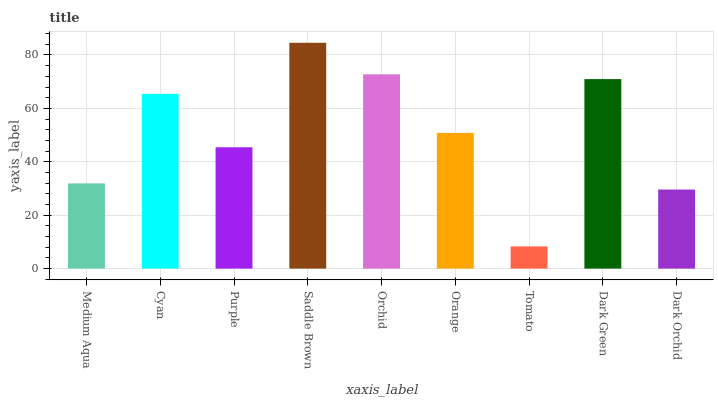Is Tomato the minimum?
Answer yes or no. Yes. Is Saddle Brown the maximum?
Answer yes or no. Yes. Is Cyan the minimum?
Answer yes or no. No. Is Cyan the maximum?
Answer yes or no. No. Is Cyan greater than Medium Aqua?
Answer yes or no. Yes. Is Medium Aqua less than Cyan?
Answer yes or no. Yes. Is Medium Aqua greater than Cyan?
Answer yes or no. No. Is Cyan less than Medium Aqua?
Answer yes or no. No. Is Orange the high median?
Answer yes or no. Yes. Is Orange the low median?
Answer yes or no. Yes. Is Purple the high median?
Answer yes or no. No. Is Medium Aqua the low median?
Answer yes or no. No. 